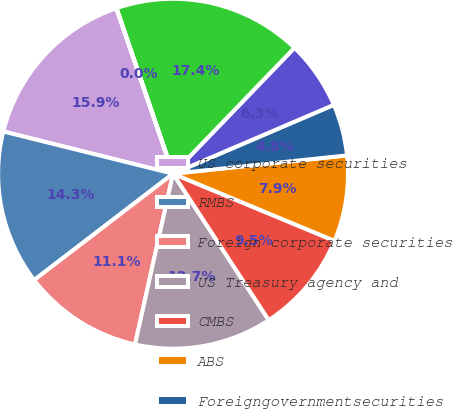Convert chart. <chart><loc_0><loc_0><loc_500><loc_500><pie_chart><fcel>US corporate securities<fcel>RMBS<fcel>Foreign corporate securities<fcel>US Treasury agency and<fcel>CMBS<fcel>ABS<fcel>Foreigngovernmentsecurities<fcel>State and political<fcel>Total fixed maturity<fcel>Commonstock<nl><fcel>15.87%<fcel>14.28%<fcel>11.11%<fcel>12.7%<fcel>9.52%<fcel>7.94%<fcel>4.77%<fcel>6.35%<fcel>17.45%<fcel>0.01%<nl></chart> 